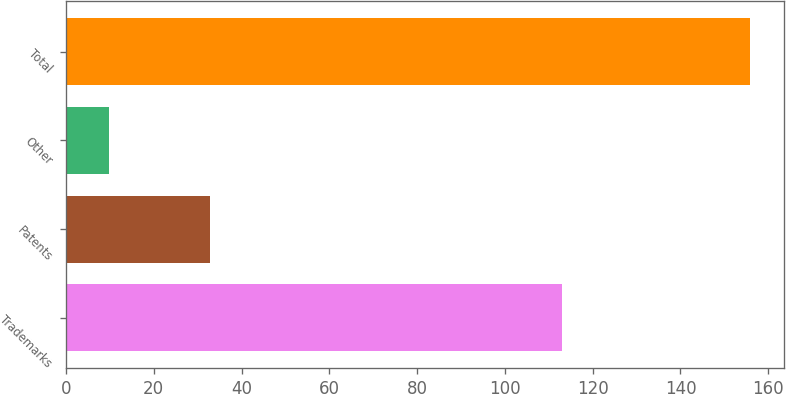Convert chart. <chart><loc_0><loc_0><loc_500><loc_500><bar_chart><fcel>Trademarks<fcel>Patents<fcel>Other<fcel>Total<nl><fcel>113<fcel>32.9<fcel>9.9<fcel>155.8<nl></chart> 